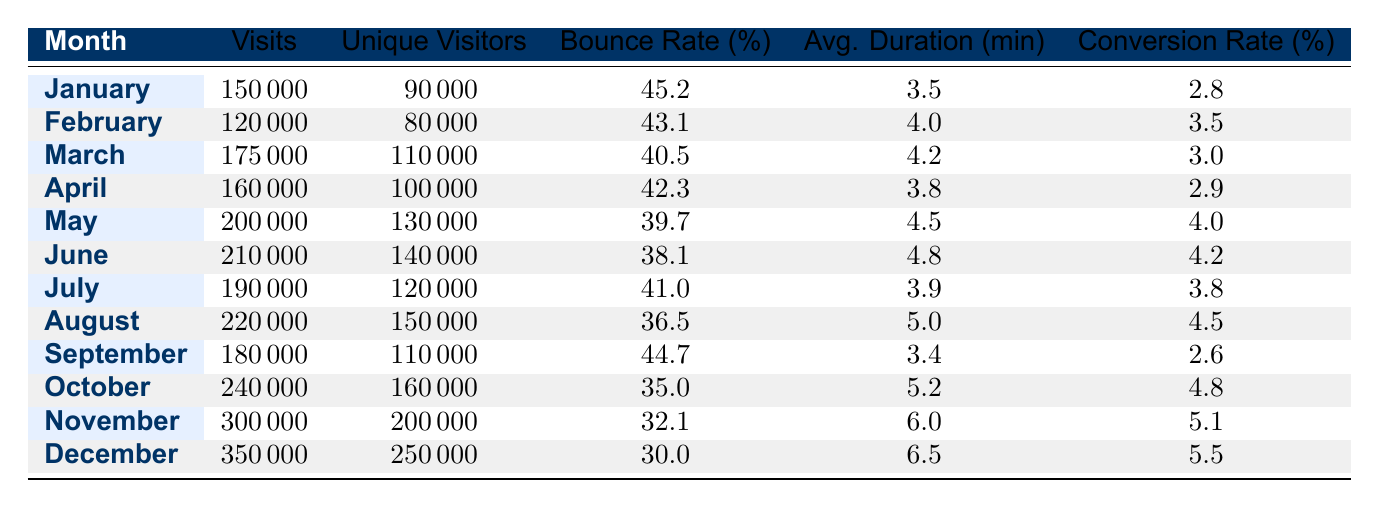What was the highest number of visits in a month? By examining the 'Visits' column, the maximum value is found in December, which has 350000 visits.
Answer: 350000 Which month had the lowest bounce rate? Observing the 'Bounce Rate' column, December has the lowest bounce rate of 30.0 percent compared to other months.
Answer: 30.0 What is the average conversion rate for the first half of the year (January to June)? To find the average conversion rate, sum the conversion rates of January (2.8), February (3.5), March (3.0), April (2.9), May (4.0), and June (4.2): 2.8 + 3.5 + 3.0 + 2.9 + 4.0 + 4.2 = 20.4. Then divide by the number of months, which is 6: 20.4 / 6 = 3.4.
Answer: 3.4 Did the number of unique visitors increase every month? Comparing the 'Unique Visitors' for each month, we notice fluctuations; the number decreased from February to March. Therefore, the statement is false.
Answer: No Which month had the longest average duration spent by visitors? Checking the 'Avg. Duration (min)' column, December has the longest average duration of 6.5 minutes, which is higher than all other months.
Answer: 6.5 What was the total number of visits from July to September? To calculate the total visits, add the number of visits from July (190000), August (220000), and September (180000): 190000 + 220000 + 180000 = 590000.
Answer: 590000 Was the conversion rate higher in October than in November? By examining the 'Conversion Rate (%)' column, October shows a conversion rate of 4.8 percent while November shows 5.1 percent, thus November is higher. Therefore, the statement is false.
Answer: No What was the average bounce rate for the second half of the year (July to December)? Add up the bounce rates from July (41.0), August (36.5), September (44.7), October (35.0), November (32.1), and December (30.0): 41.0 + 36.5 + 44.7 + 35.0 + 32.1 + 30.0 = 219.3. Divide by the number of months (6): 219.3 / 6 = 36.55.
Answer: 36.55 